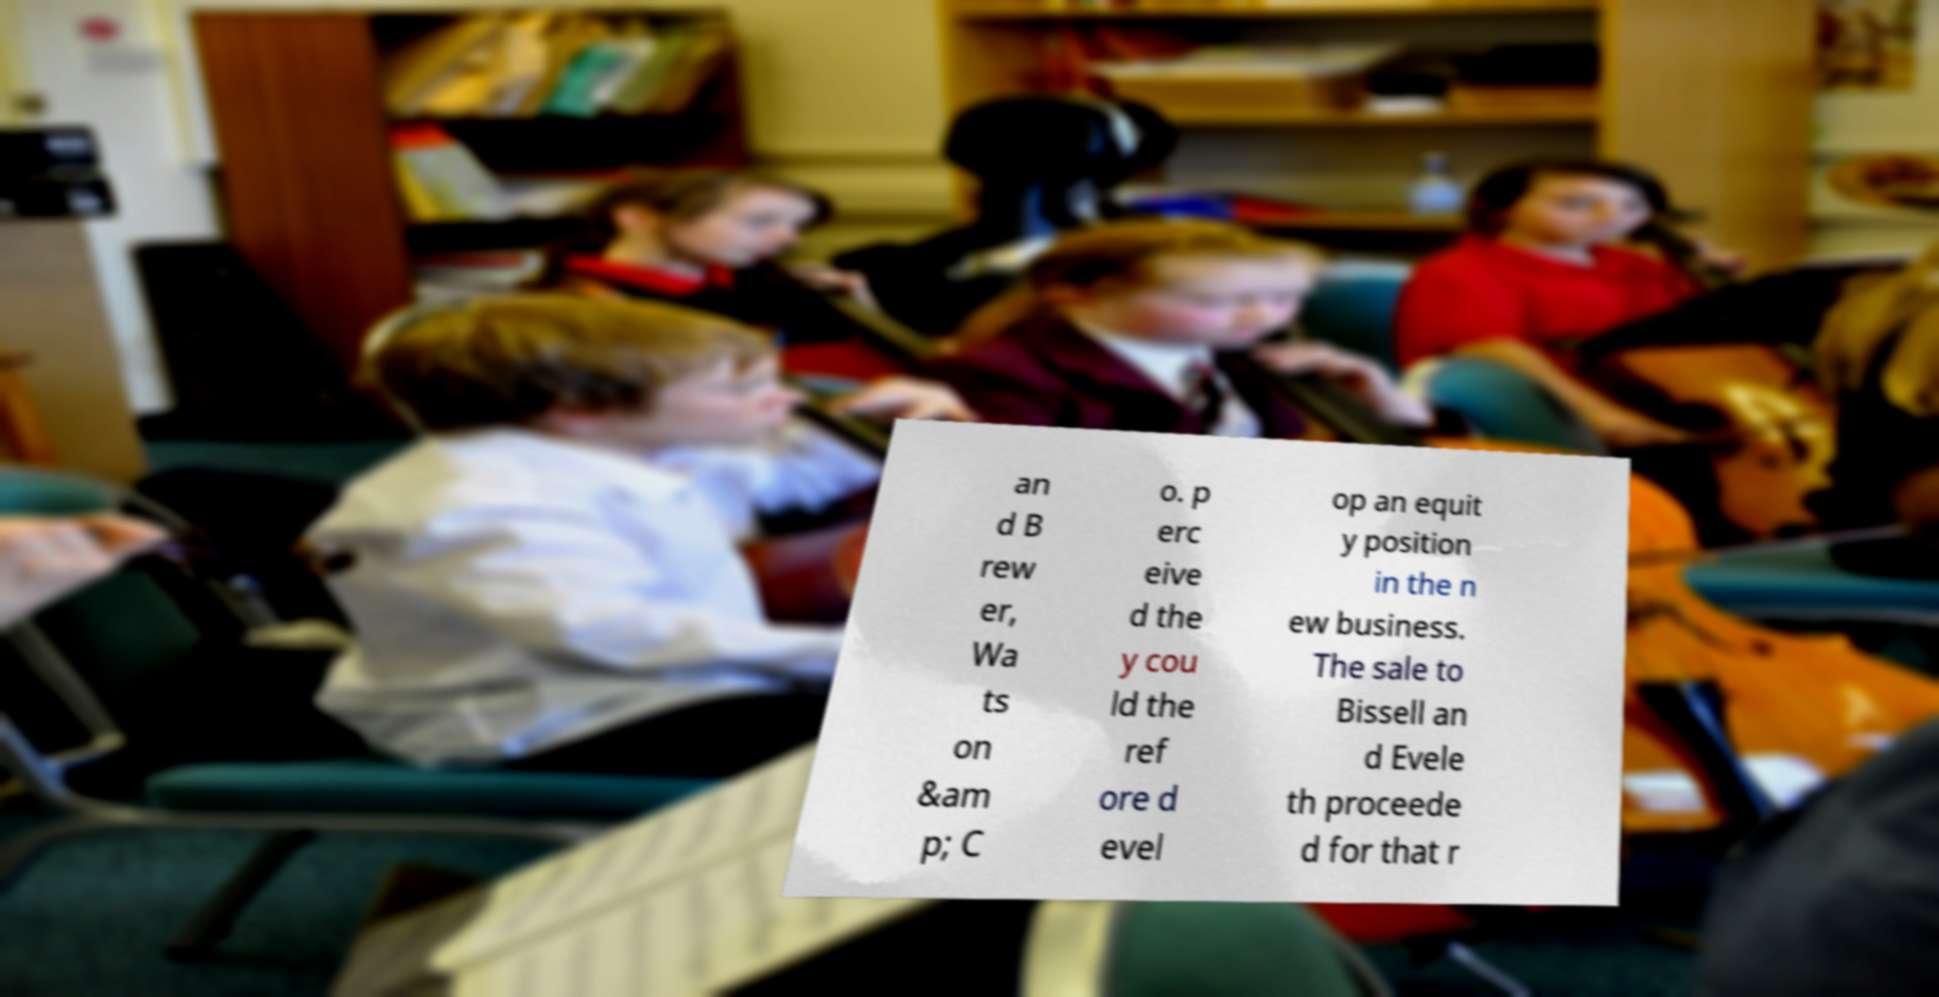There's text embedded in this image that I need extracted. Can you transcribe it verbatim? an d B rew er, Wa ts on &am p; C o. p erc eive d the y cou ld the ref ore d evel op an equit y position in the n ew business. The sale to Bissell an d Evele th proceede d for that r 